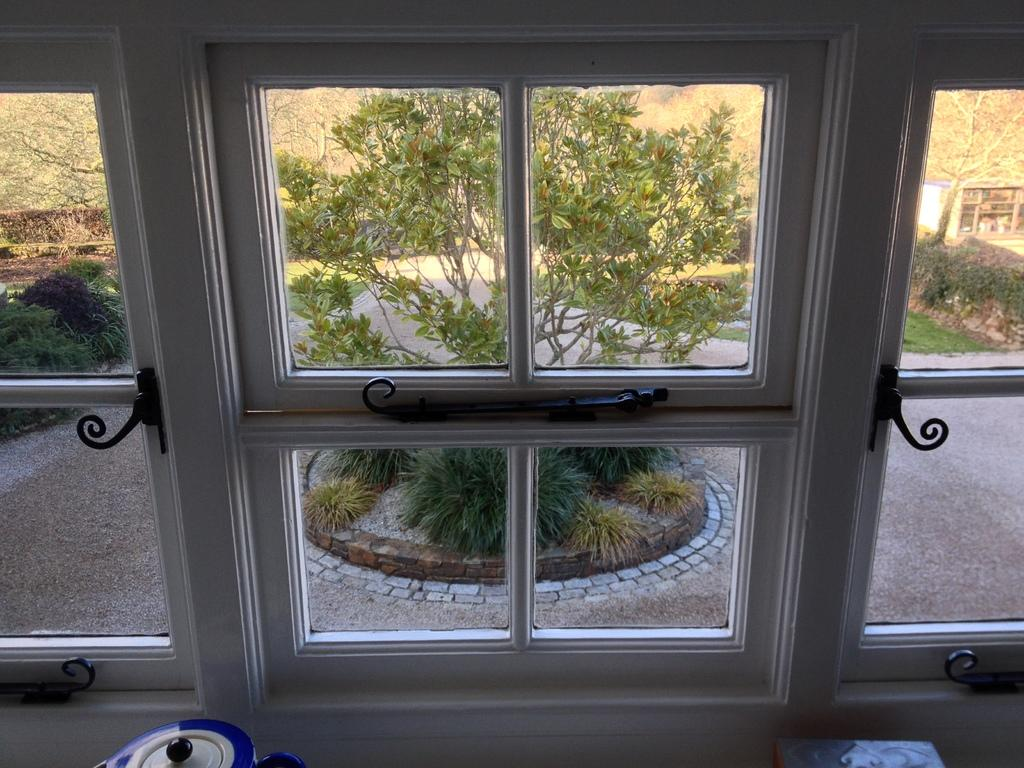What type of window is visible in the image? There is a glass window in the image. What color is the glass window? The glass window is white in color. What can be seen in the background of the image? There are trees in the background of the image. How does the beginner use paste to solve arithmetic problems in the image? There is no reference to a beginner, paste, or arithmetic problems in the image, so it is not possible to answer that question. 